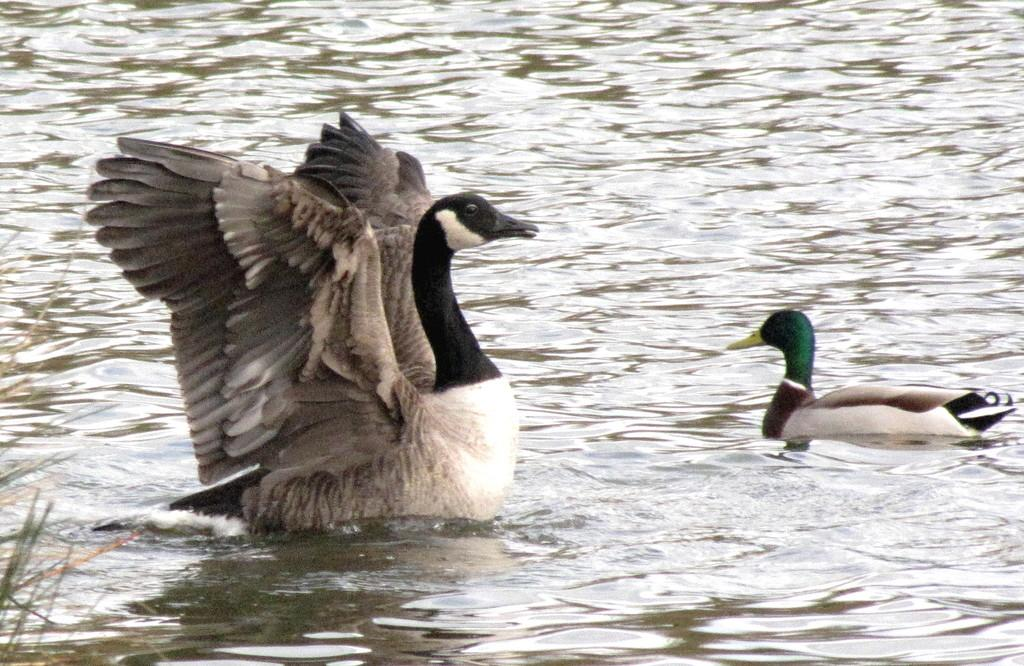What type of animals are in the image? There are aquatic birds in the image. Where are the birds located in the image? The birds are in the water. What type of locket is hanging from the neck of the bird in the image? There is no locket visible on the bird in the image. Can you see any smoke coming from the water in the image? There is no smoke present in the image. 